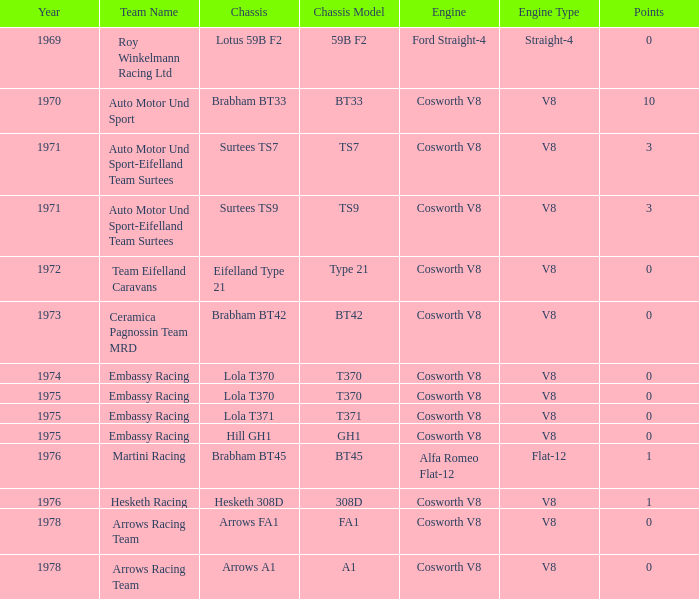Who was the entrant in 1971? Auto Motor Und Sport-Eifelland Team Surtees, Auto Motor Und Sport-Eifelland Team Surtees. 